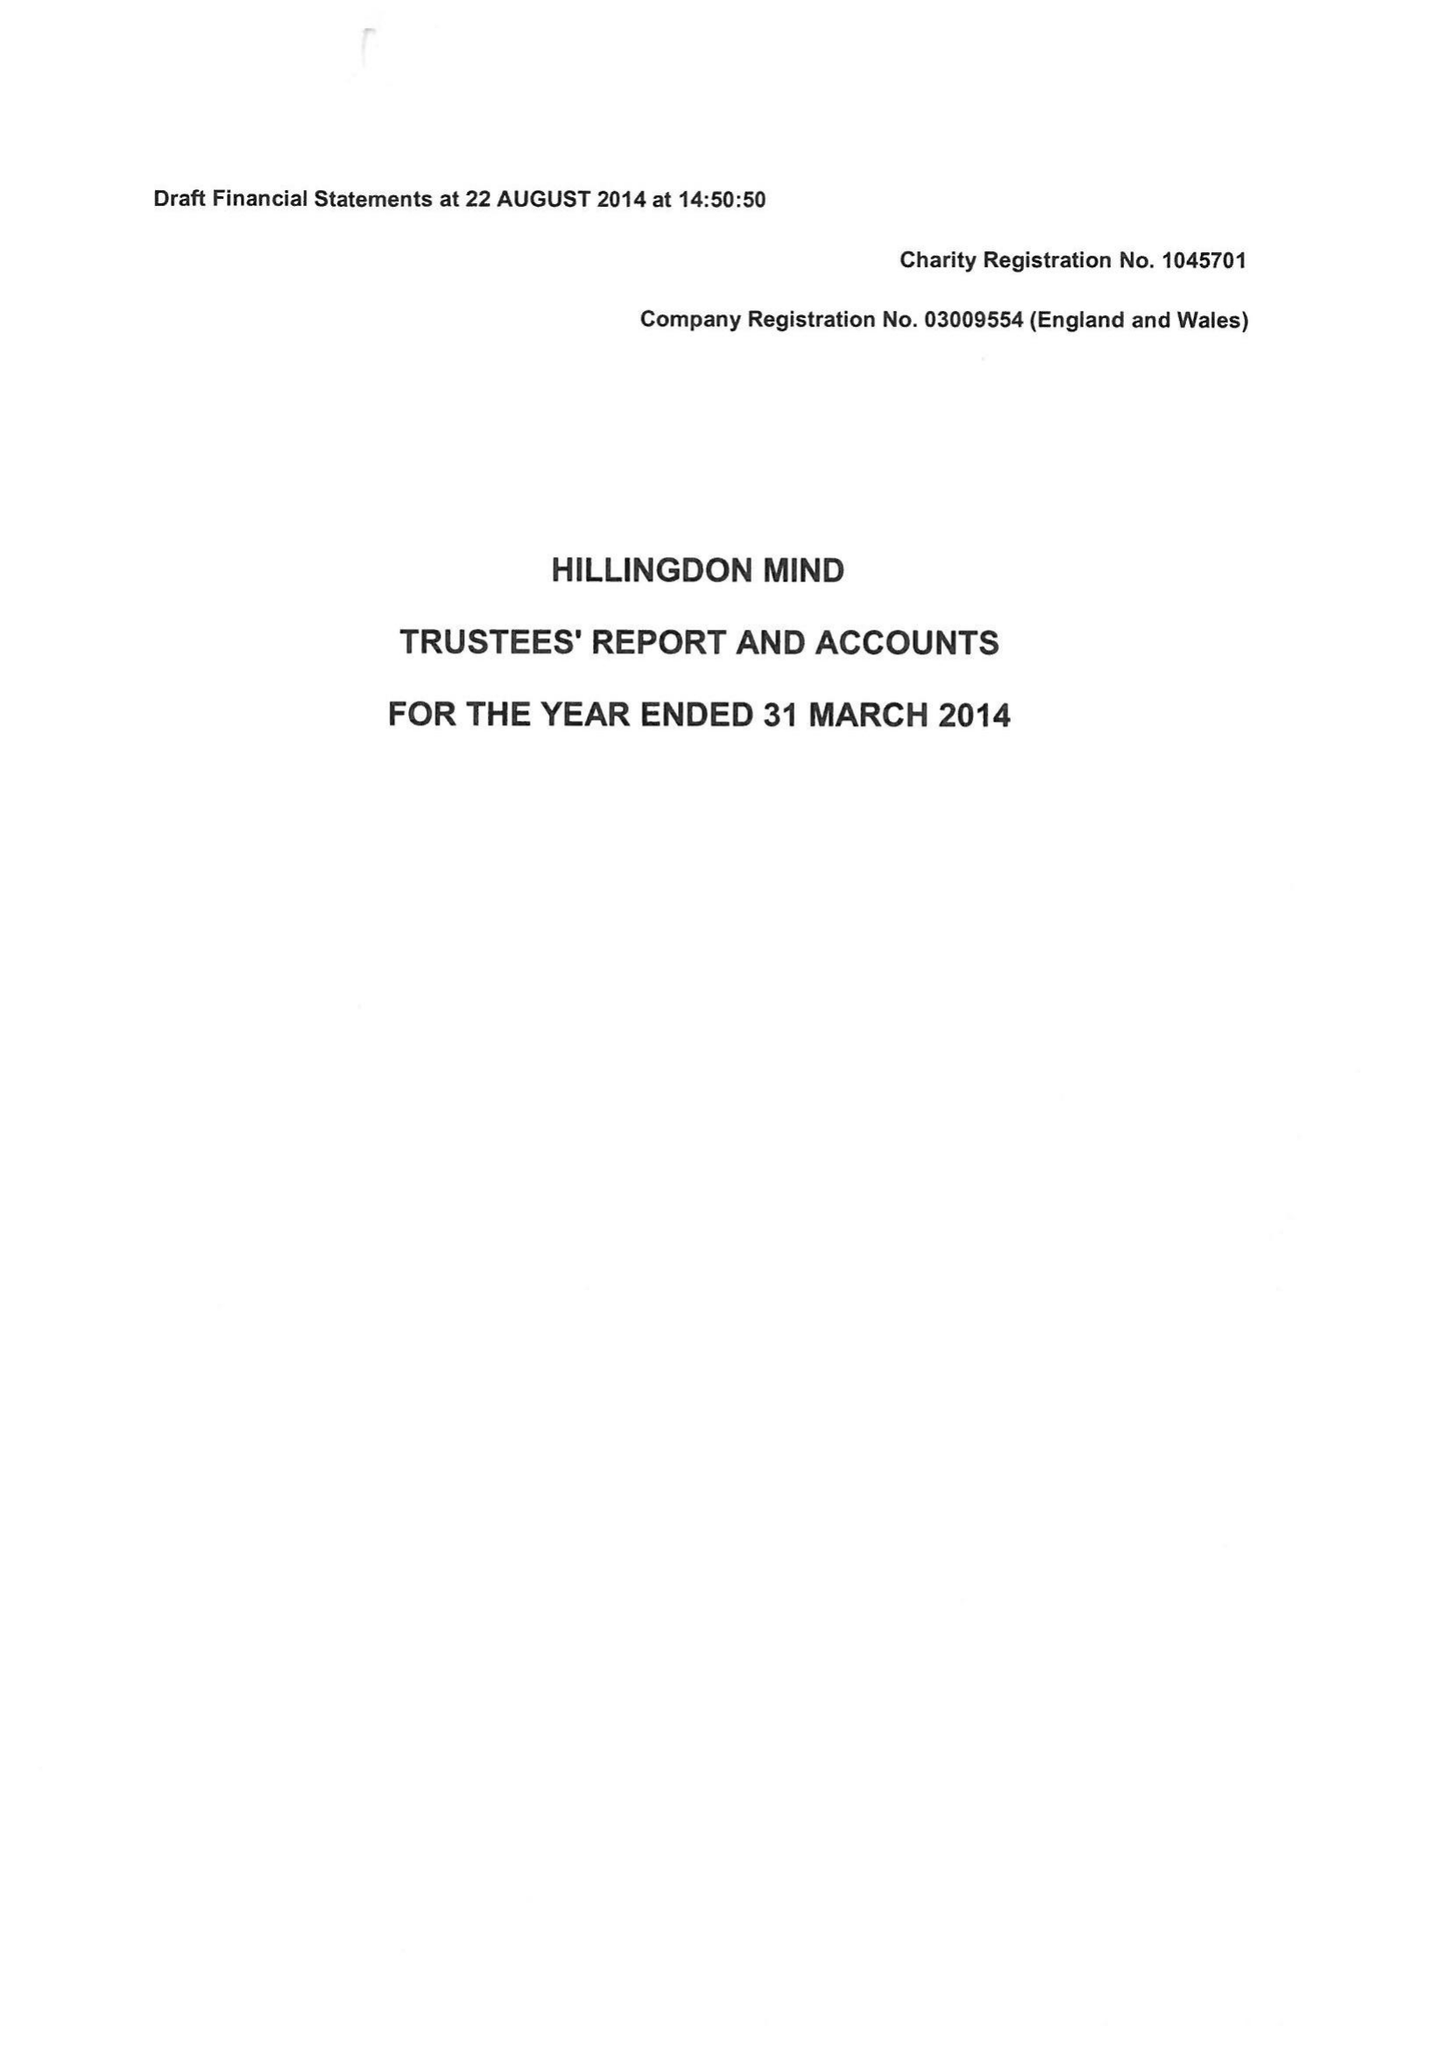What is the value for the address__street_line?
Answer the question using a single word or phrase. 40 NEW WINDSOR STREET 